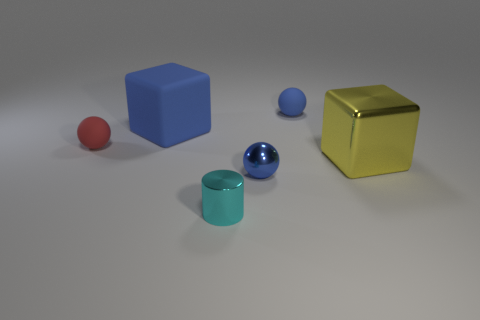Add 2 small red shiny things. How many objects exist? 8 Subtract all blue balls. How many balls are left? 1 Subtract all small rubber spheres. How many spheres are left? 1 Subtract all cylinders. How many objects are left? 5 Subtract 1 blocks. How many blocks are left? 1 Add 6 metallic cubes. How many metallic cubes are left? 7 Add 4 big brown rubber balls. How many big brown rubber balls exist? 4 Subtract 1 cyan cylinders. How many objects are left? 5 Subtract all brown balls. Subtract all gray cylinders. How many balls are left? 3 Subtract all green cylinders. How many yellow cubes are left? 1 